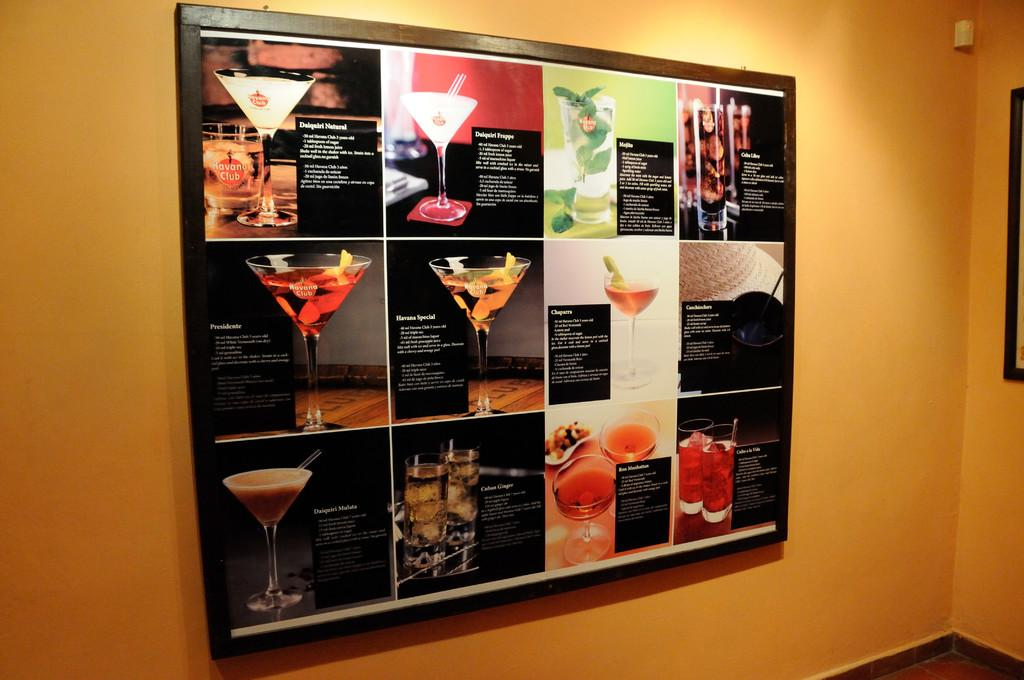What is the main subject of the image in the picture? There is a menu poster in the image. What type of items are listed on the poster? The poster contains drinks. Are there any textual elements on the poster? Yes, there are words written on the poster. Where is the poster located in the image? The poster is attached to a wall. What color is the wall the poster is attached to? The wall is yellow in color. Can you see a shoe floating in the river in the image? There is no shoe or river present in the image; it features a menu poster attached to a yellow wall. 